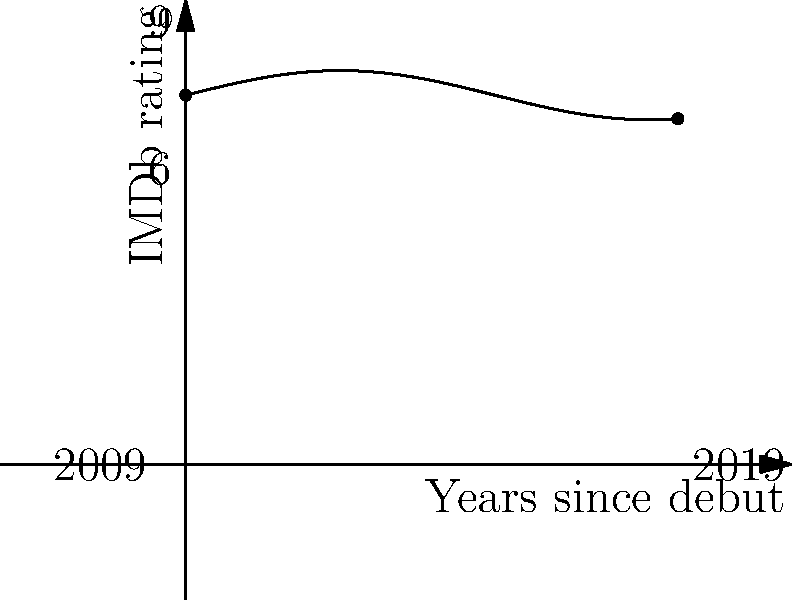The graph represents Gillian Jacobs' IMDb ratings over a 10-year period since her debut in 2009. If the function describing her ratings is given by $f(x) = 0.5\sin(\frac{x}{2}) + 7.5$, where $x$ represents years since debut, calculate the average IMDb rating for Gillian Jacobs over this period using the concept of definite integrals. To find the average IMDb rating, we need to:

1. Calculate the area under the curve using a definite integral.
2. Divide the area by the time period to get the average.

Step 1: Set up the definite integral
$$\int_0^{10} (0.5\sin(\frac{x}{2}) + 7.5) dx$$

Step 2: Integrate
$$[0.5(-2\cos(\frac{x}{2})) + 7.5x]_0^{10}$$

Step 3: Evaluate the integral
$$(0.5(-2\cos(5)) + 75) - (0.5(-2\cos(0)) + 0)$$
$$= (-\cos(5) + 75) - (-1 + 0)$$
$$= -\cos(5) + 76$$

Step 4: Calculate the average by dividing by the time period (10 years)
$$\frac{-\cos(5) + 76}{10}$$

Step 5: Simplify
$$7.6 - 0.1\cos(5) \approx 7.5284$$

Therefore, the average IMDb rating for Gillian Jacobs over this 10-year period is approximately 7.53.
Answer: 7.53 